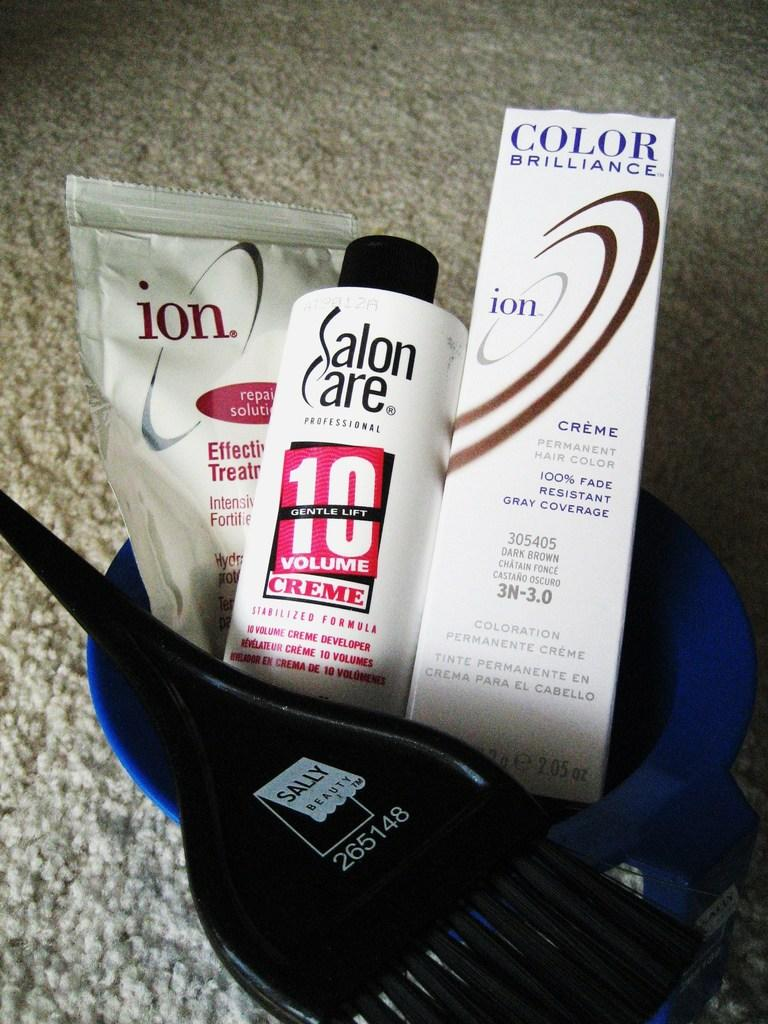<image>
Provide a brief description of the given image. Face care products including a brush and a bottle saying Salon Care. 